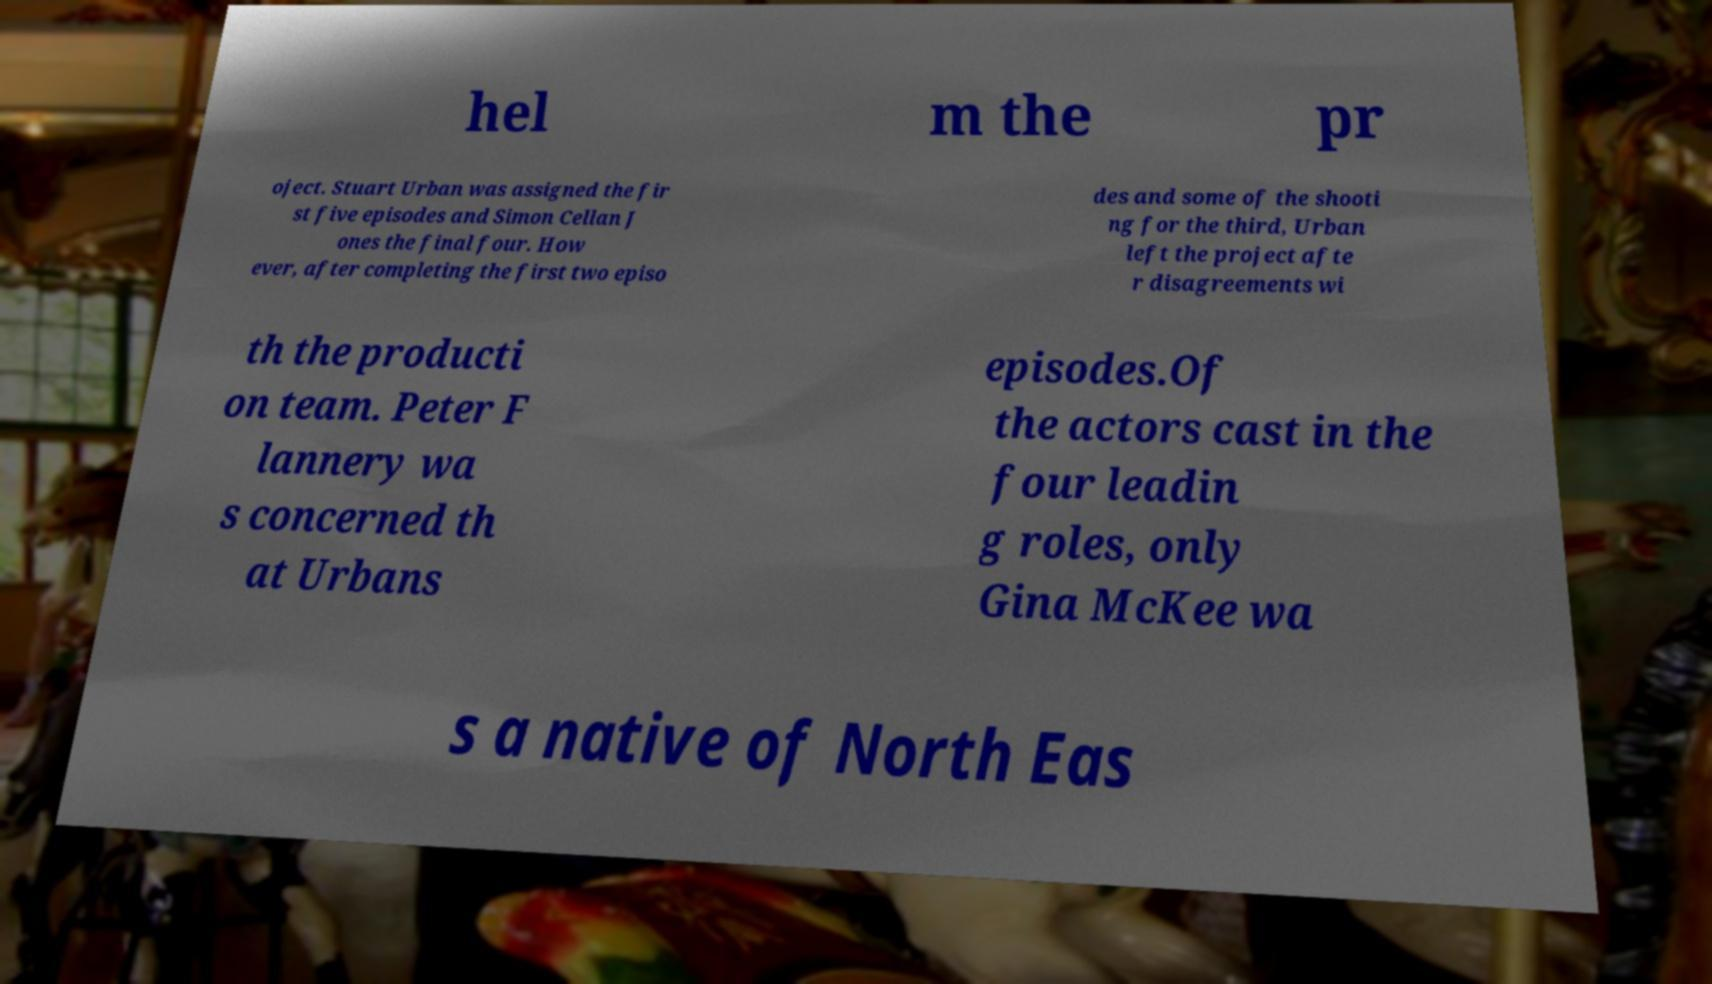Please read and relay the text visible in this image. What does it say? hel m the pr oject. Stuart Urban was assigned the fir st five episodes and Simon Cellan J ones the final four. How ever, after completing the first two episo des and some of the shooti ng for the third, Urban left the project afte r disagreements wi th the producti on team. Peter F lannery wa s concerned th at Urbans episodes.Of the actors cast in the four leadin g roles, only Gina McKee wa s a native of North Eas 